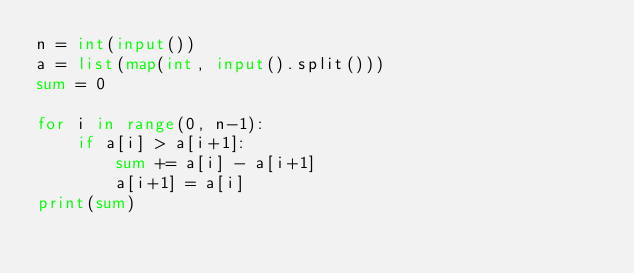<code> <loc_0><loc_0><loc_500><loc_500><_Python_>n = int(input())
a = list(map(int, input().split()))
sum = 0

for i in range(0, n-1):
    if a[i] > a[i+1]:
        sum += a[i] - a[i+1]
        a[i+1] = a[i]
print(sum)</code> 